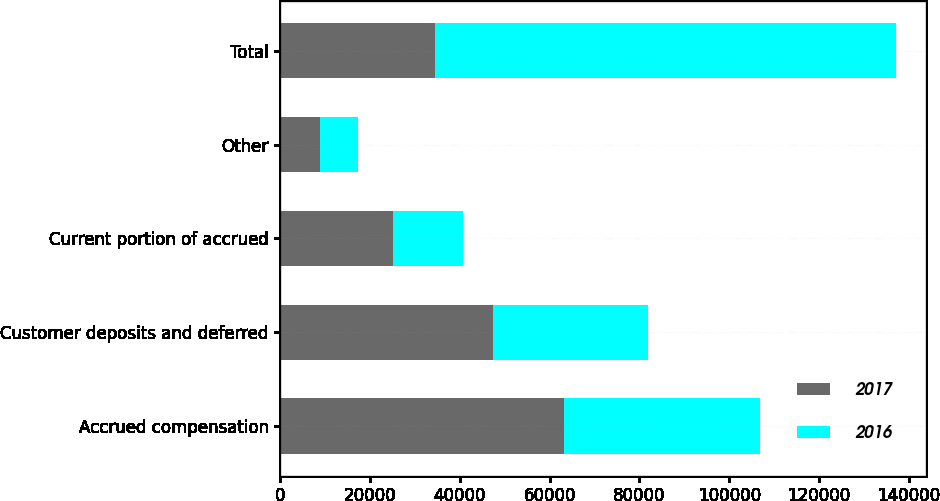Convert chart. <chart><loc_0><loc_0><loc_500><loc_500><stacked_bar_chart><ecel><fcel>Accrued compensation<fcel>Customer deposits and deferred<fcel>Current portion of accrued<fcel>Other<fcel>Total<nl><fcel>2017<fcel>63203<fcel>47324<fcel>25059<fcel>8831<fcel>34571<nl><fcel>2016<fcel>43761<fcel>34571<fcel>15711<fcel>8442<fcel>102485<nl></chart> 